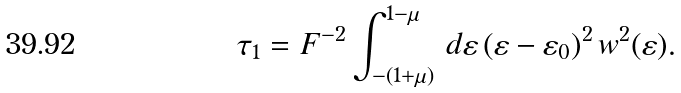Convert formula to latex. <formula><loc_0><loc_0><loc_500><loc_500>\tau _ { 1 } = F ^ { - 2 } \int ^ { 1 - \mu } _ { - ( 1 + \mu ) } \, d \varepsilon \, ( \varepsilon - \varepsilon _ { 0 } ) ^ { 2 } \, w ^ { 2 } ( \varepsilon ) .</formula> 